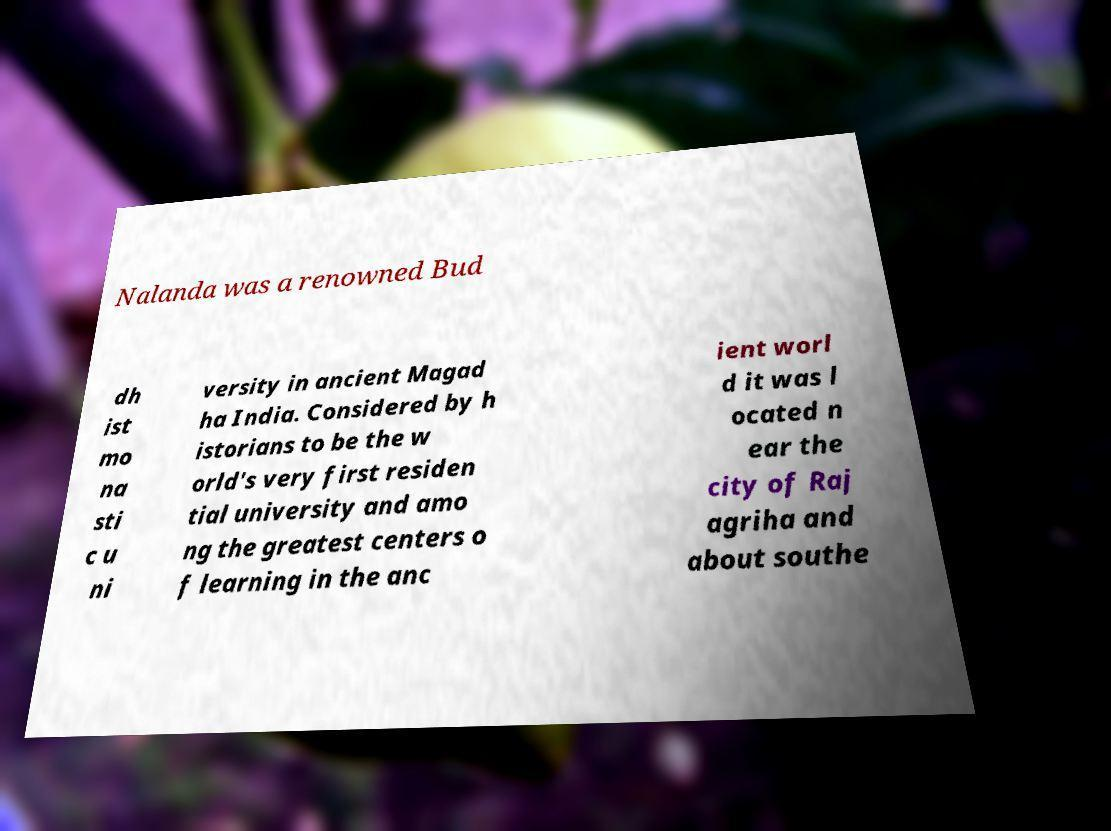Can you accurately transcribe the text from the provided image for me? Nalanda was a renowned Bud dh ist mo na sti c u ni versity in ancient Magad ha India. Considered by h istorians to be the w orld's very first residen tial university and amo ng the greatest centers o f learning in the anc ient worl d it was l ocated n ear the city of Raj agriha and about southe 